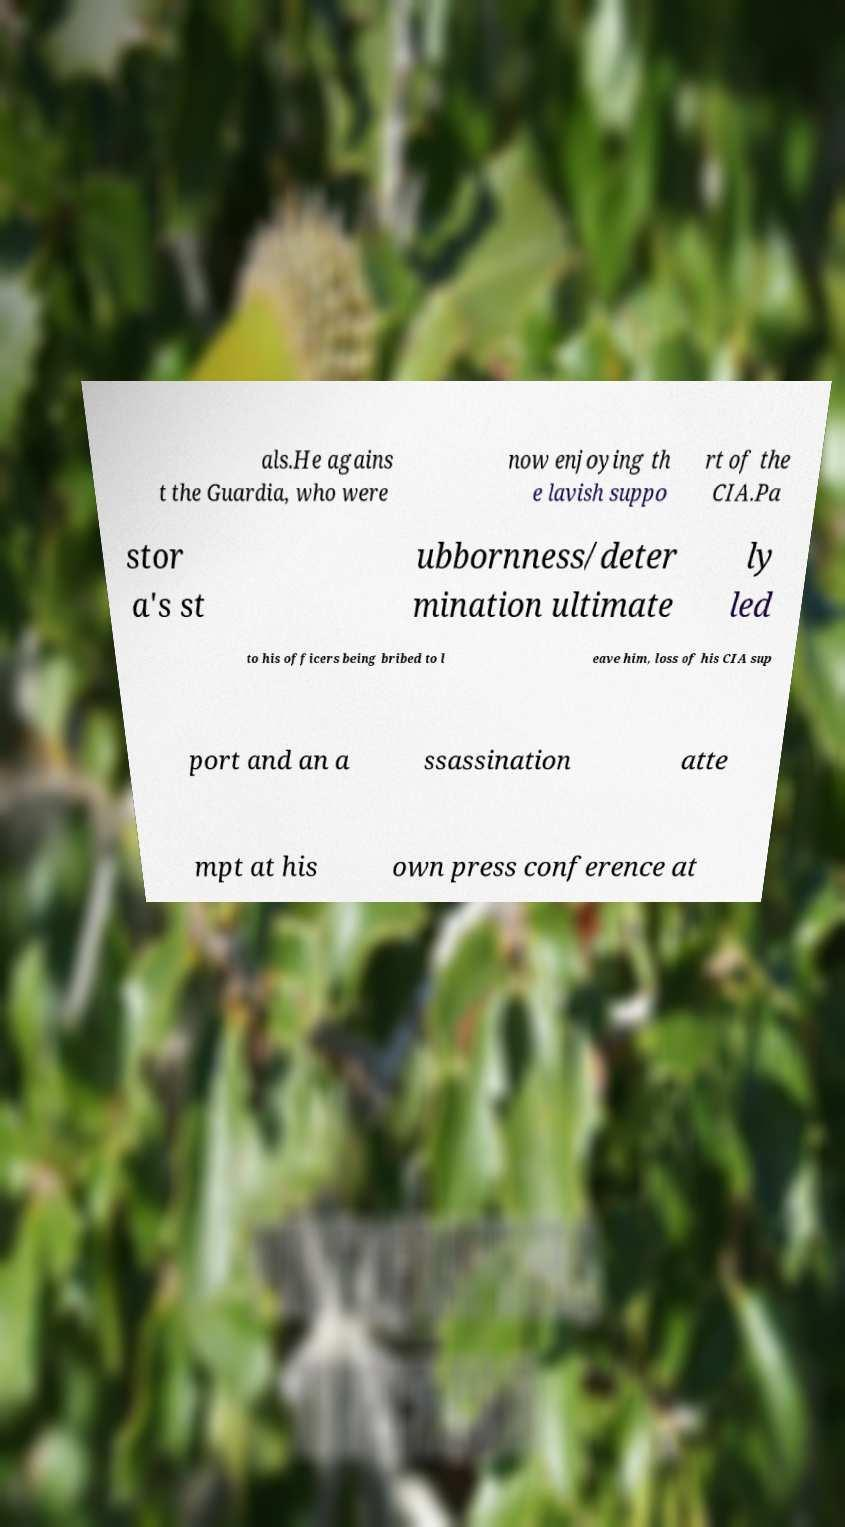I need the written content from this picture converted into text. Can you do that? als.He agains t the Guardia, who were now enjoying th e lavish suppo rt of the CIA.Pa stor a's st ubbornness/deter mination ultimate ly led to his officers being bribed to l eave him, loss of his CIA sup port and an a ssassination atte mpt at his own press conference at 